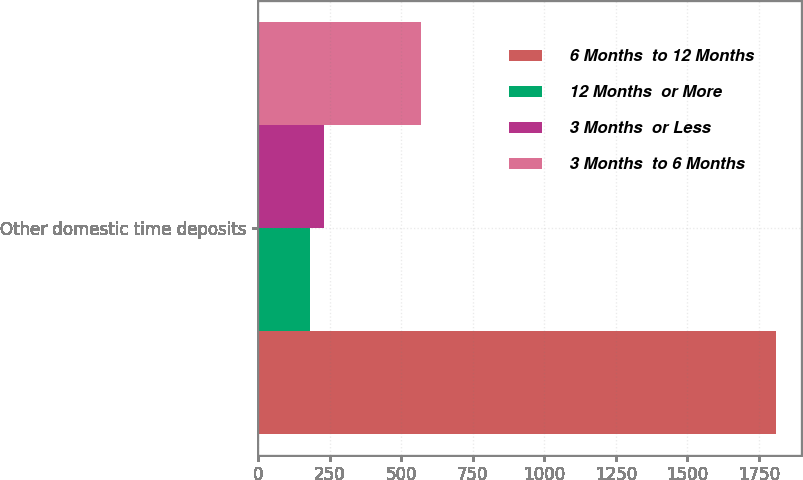Convert chart. <chart><loc_0><loc_0><loc_500><loc_500><stacked_bar_chart><ecel><fcel>Other domestic time deposits<nl><fcel>6 Months  to 12 Months<fcel>1809<nl><fcel>12 Months  or More<fcel>179<nl><fcel>3 Months  or Less<fcel>229<nl><fcel>3 Months  to 6 Months<fcel>568<nl></chart> 